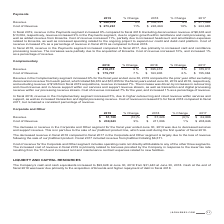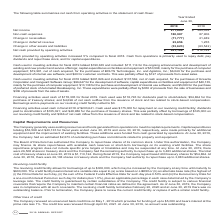From Jack Henry Associates's financial document, What is the net income in 2018 and 2019 respectively? The document shows two values: $365,034 and $271,885. From the document: "Net income $ 271,885 $ 365,034 Net income $ 271,885 $ 365,034..." Also, What is the non-cash expenses in 2018 and 2019 respectively? The document shows two values: 87,906 and 180,987. From the document: "Non-cash expenses 180,987 87,906 Non-cash expenses 180,987 87,906..." Also, What does the table show? summarizes net cash from operating activities in the statement of cash flows. The document states: "The following table summarizes net cash from operating activities in the statement of cash flows:..." Also, can you calculate: What is the change in net cash provided by operating activities from 2018 to 2019? Based on the calculation: $431,128-$412,142, the result is 18986. This is based on the information: "cash provided by operating activities $ 431,128 $ 412,142 Net cash provided by operating activities $ 431,128 $ 412,142..." The key data points involved are: 412,142, 431,128. Also, can you calculate: What is the average net income for 2018 and 2019? To answer this question, I need to perform calculations using the financial data. The calculation is: ($271,885+$365,034)/2, which equals 318459.5. This is based on the information: "Net income $ 271,885 $ 365,034 Net income $ 271,885 $ 365,034..." The key data points involved are: 271,885, 365,034. Also, can you calculate: What is the average net cash provided by operating activities for 2018 and 2019? To answer this question, I need to perform calculations using the financial data. The calculation is: ($431,128+$412,142)/2, which equals 421635. This is based on the information: "cash provided by operating activities $ 431,128 $ 412,142 Net cash provided by operating activities $ 431,128 $ 412,142..." The key data points involved are: 412,142, 431,128. 